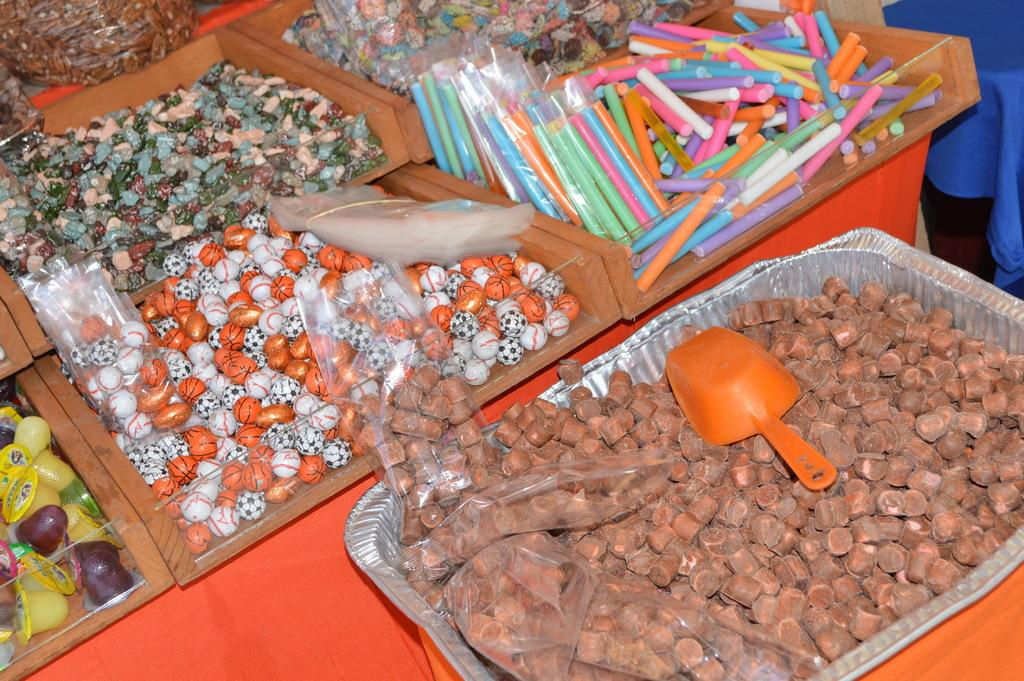What can be seen in the image that holds objects? There are containers in the image. What types of objects are stored in the containers? The containers hold different varieties of objects. What type of thunder can be heard coming from the containers in the image? There is no thunder present in the image, as it features containers holding objects. 